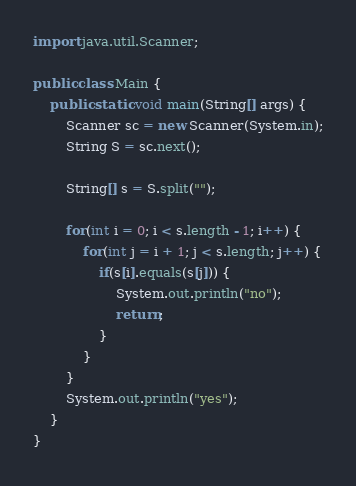<code> <loc_0><loc_0><loc_500><loc_500><_Java_>import java.util.Scanner;

public class Main {
	public static void main(String[] args) {
		Scanner sc = new Scanner(System.in);
		String S = sc.next();
		
		String[] s = S.split("");
		
		for(int i = 0; i < s.length - 1; i++) {
			for(int j = i + 1; j < s.length; j++) {
				if(s[i].equals(s[j])) {
					System.out.println("no");
					return;
				}
			}
		}
		System.out.println("yes");
	}
}
</code> 